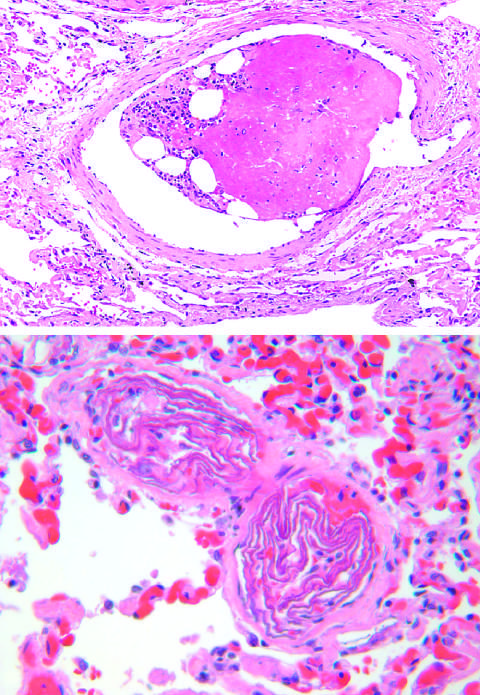what is the embolus composed of?
Answer the question using a single word or phrase. Hematopoietic marrow and marrow fat cells 